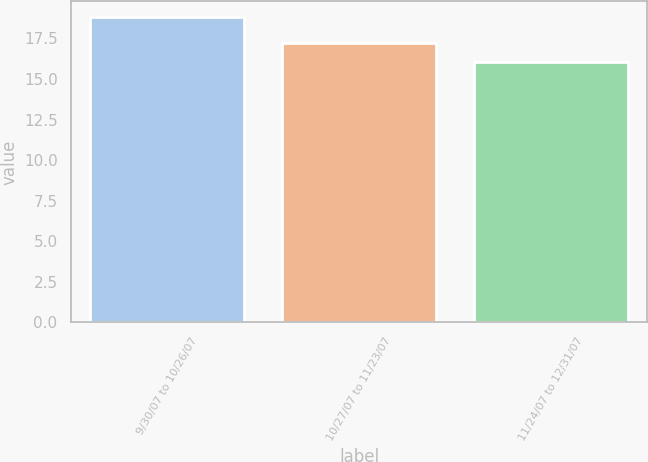Convert chart to OTSL. <chart><loc_0><loc_0><loc_500><loc_500><bar_chart><fcel>9/30/07 to 10/26/07<fcel>10/27/07 to 11/23/07<fcel>11/24/07 to 12/31/07<nl><fcel>18.84<fcel>17.23<fcel>16.04<nl></chart> 